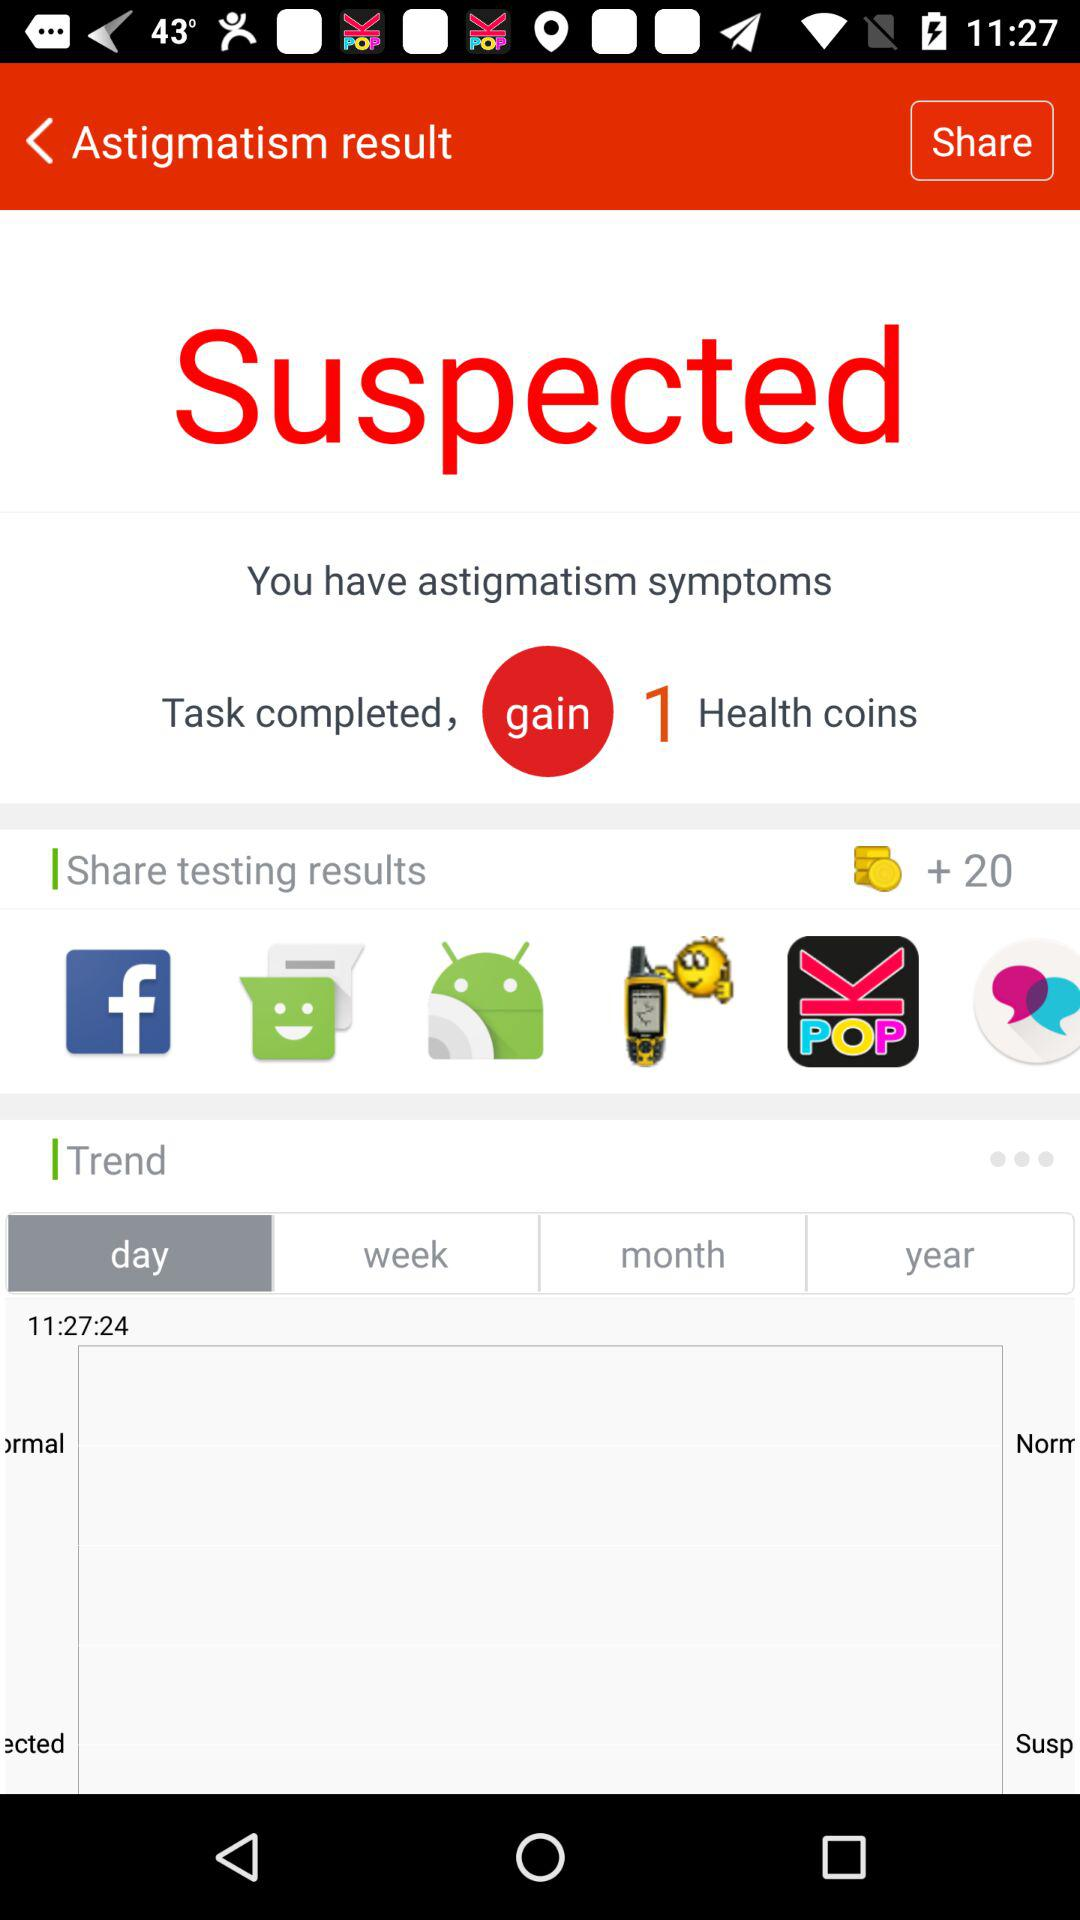How many health coins did I gain?
Answer the question using a single word or phrase. 20 